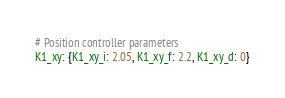<code> <loc_0><loc_0><loc_500><loc_500><_YAML_># Position controller parameters
K1_xy: {K1_xy_i: 2.05, K1_xy_f: 2.2, K1_xy_d: 0}</code> 